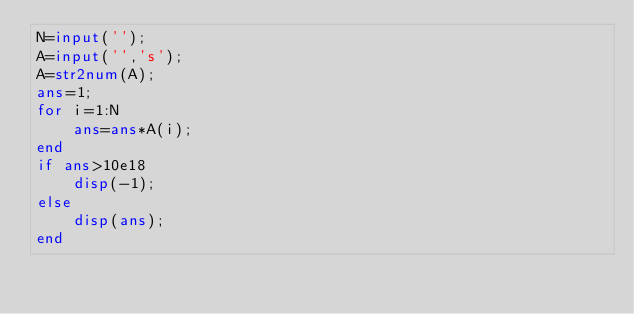Convert code to text. <code><loc_0><loc_0><loc_500><loc_500><_Octave_>N=input('');
A=input('','s');
A=str2num(A);
ans=1;
for i=1:N
	ans=ans*A(i);
end
if ans>10e18
	disp(-1);
else
	disp(ans);
end</code> 